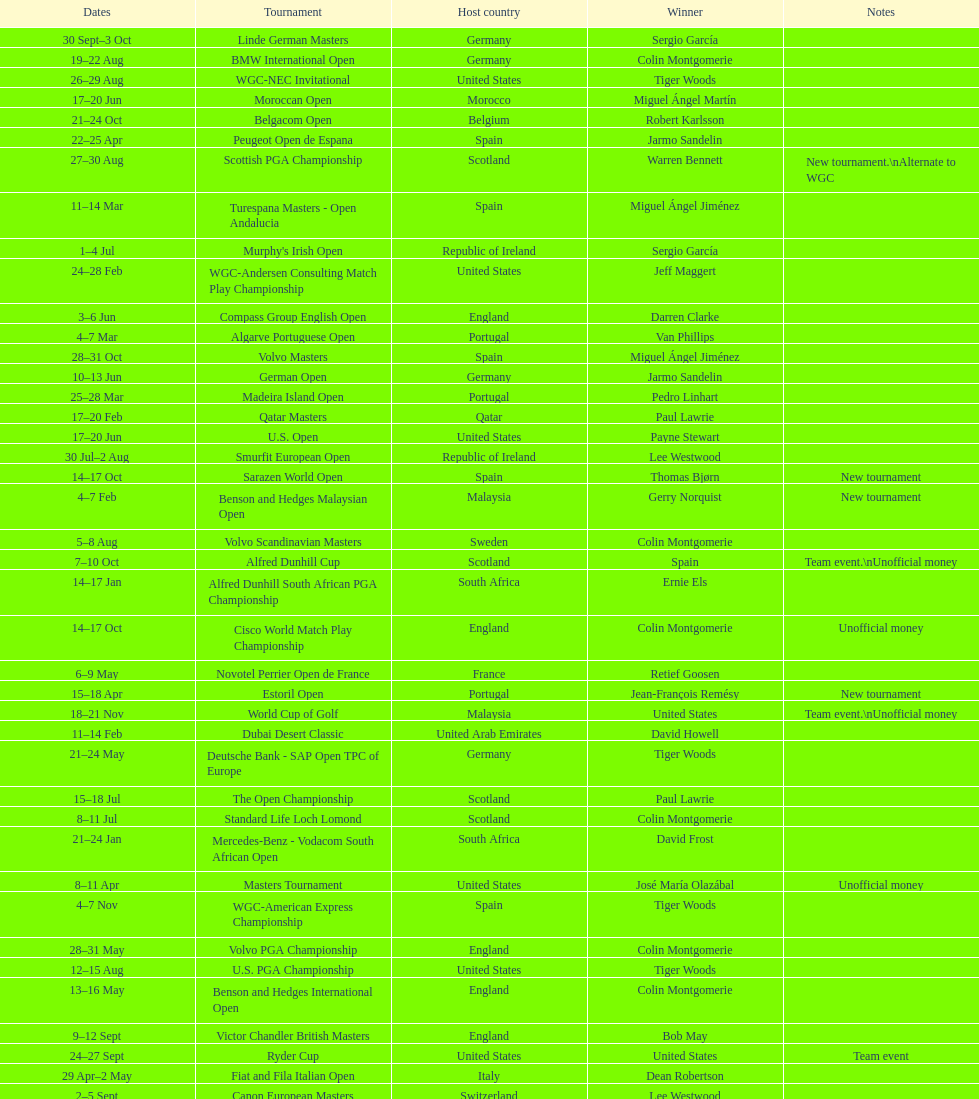Does any country have more than 5 winners? Yes. 